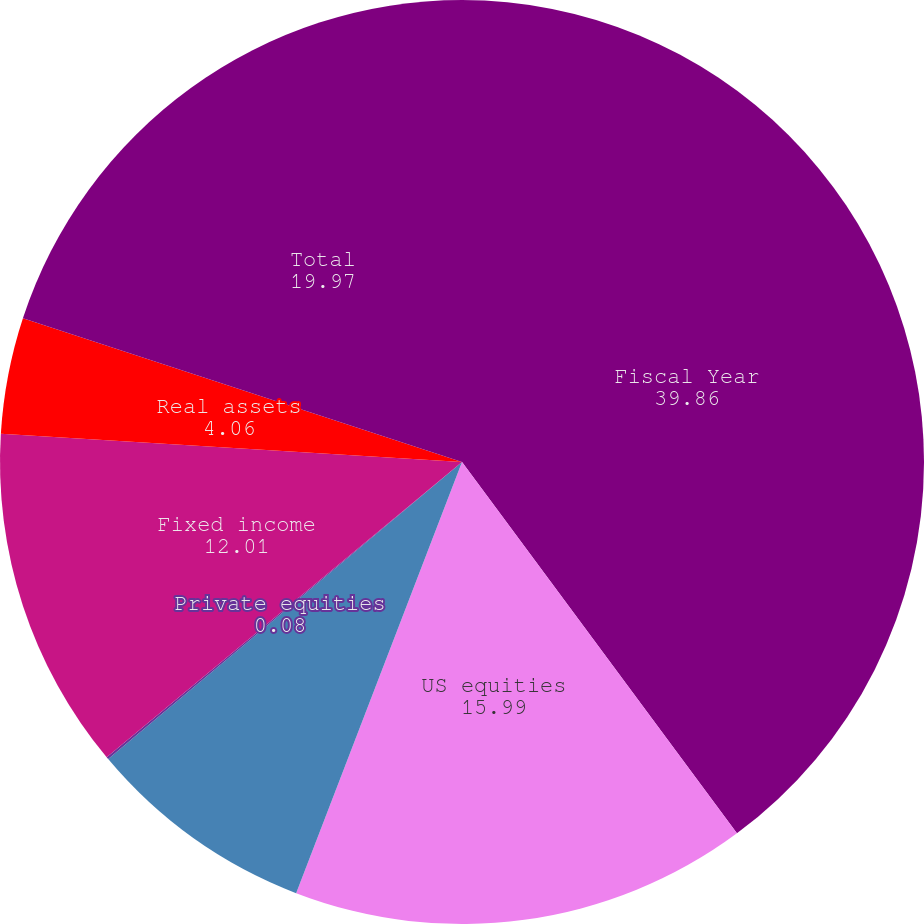Convert chart to OTSL. <chart><loc_0><loc_0><loc_500><loc_500><pie_chart><fcel>Fiscal Year<fcel>US equities<fcel>International equities<fcel>Private equities<fcel>Fixed income<fcel>Real assets<fcel>Total<nl><fcel>39.86%<fcel>15.99%<fcel>8.04%<fcel>0.08%<fcel>12.01%<fcel>4.06%<fcel>19.97%<nl></chart> 